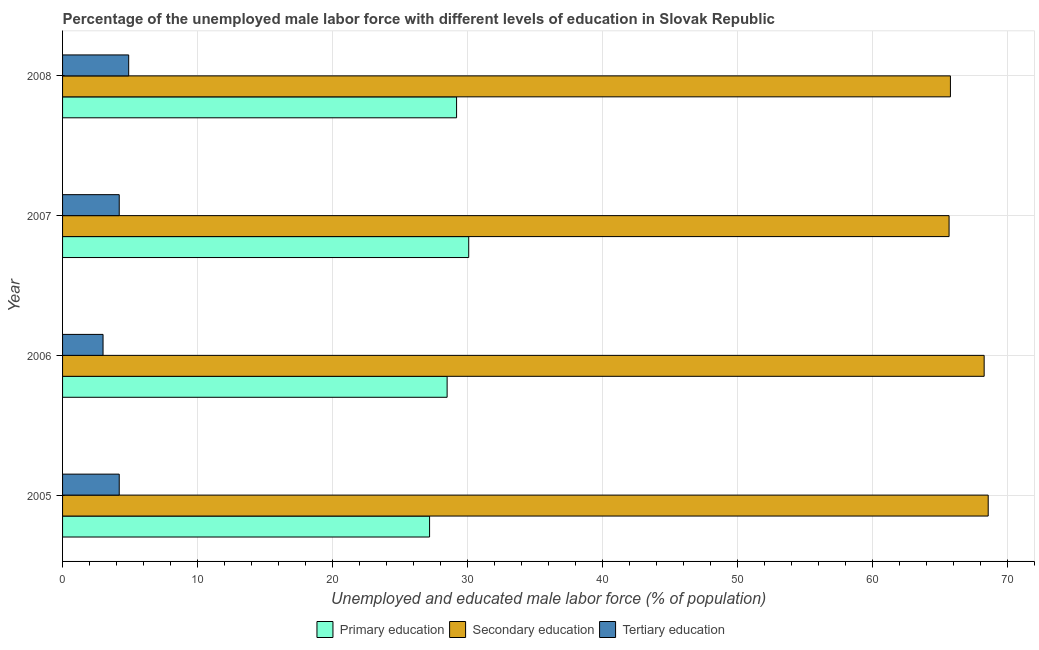How many groups of bars are there?
Offer a very short reply. 4. Are the number of bars per tick equal to the number of legend labels?
Make the answer very short. Yes. How many bars are there on the 4th tick from the bottom?
Ensure brevity in your answer.  3. What is the label of the 3rd group of bars from the top?
Give a very brief answer. 2006. In how many cases, is the number of bars for a given year not equal to the number of legend labels?
Offer a terse response. 0. What is the percentage of male labor force who received tertiary education in 2005?
Keep it short and to the point. 4.2. Across all years, what is the maximum percentage of male labor force who received primary education?
Provide a short and direct response. 30.1. Across all years, what is the minimum percentage of male labor force who received secondary education?
Your answer should be compact. 65.7. What is the total percentage of male labor force who received tertiary education in the graph?
Keep it short and to the point. 16.3. What is the difference between the percentage of male labor force who received primary education in 2005 and that in 2008?
Provide a succinct answer. -2. What is the difference between the percentage of male labor force who received secondary education in 2006 and the percentage of male labor force who received primary education in 2005?
Offer a very short reply. 41.1. What is the average percentage of male labor force who received tertiary education per year?
Provide a short and direct response. 4.08. In the year 2008, what is the difference between the percentage of male labor force who received secondary education and percentage of male labor force who received tertiary education?
Your answer should be compact. 60.9. What is the ratio of the percentage of male labor force who received secondary education in 2005 to that in 2008?
Offer a very short reply. 1.04. Is the percentage of male labor force who received tertiary education in 2005 less than that in 2007?
Make the answer very short. No. Is the difference between the percentage of male labor force who received secondary education in 2006 and 2007 greater than the difference between the percentage of male labor force who received tertiary education in 2006 and 2007?
Give a very brief answer. Yes. What is the difference between the highest and the lowest percentage of male labor force who received primary education?
Ensure brevity in your answer.  2.9. What does the 2nd bar from the top in 2006 represents?
Offer a terse response. Secondary education. What does the 3rd bar from the bottom in 2007 represents?
Provide a short and direct response. Tertiary education. How many bars are there?
Your answer should be compact. 12. How many years are there in the graph?
Make the answer very short. 4. Are the values on the major ticks of X-axis written in scientific E-notation?
Your response must be concise. No. Does the graph contain grids?
Give a very brief answer. Yes. Where does the legend appear in the graph?
Your answer should be very brief. Bottom center. How many legend labels are there?
Your response must be concise. 3. What is the title of the graph?
Ensure brevity in your answer.  Percentage of the unemployed male labor force with different levels of education in Slovak Republic. What is the label or title of the X-axis?
Your response must be concise. Unemployed and educated male labor force (% of population). What is the label or title of the Y-axis?
Your answer should be compact. Year. What is the Unemployed and educated male labor force (% of population) in Primary education in 2005?
Give a very brief answer. 27.2. What is the Unemployed and educated male labor force (% of population) in Secondary education in 2005?
Your answer should be compact. 68.6. What is the Unemployed and educated male labor force (% of population) in Tertiary education in 2005?
Keep it short and to the point. 4.2. What is the Unemployed and educated male labor force (% of population) in Primary education in 2006?
Keep it short and to the point. 28.5. What is the Unemployed and educated male labor force (% of population) of Secondary education in 2006?
Offer a terse response. 68.3. What is the Unemployed and educated male labor force (% of population) of Tertiary education in 2006?
Provide a succinct answer. 3. What is the Unemployed and educated male labor force (% of population) in Primary education in 2007?
Make the answer very short. 30.1. What is the Unemployed and educated male labor force (% of population) in Secondary education in 2007?
Keep it short and to the point. 65.7. What is the Unemployed and educated male labor force (% of population) of Tertiary education in 2007?
Provide a succinct answer. 4.2. What is the Unemployed and educated male labor force (% of population) of Primary education in 2008?
Keep it short and to the point. 29.2. What is the Unemployed and educated male labor force (% of population) of Secondary education in 2008?
Your response must be concise. 65.8. What is the Unemployed and educated male labor force (% of population) of Tertiary education in 2008?
Make the answer very short. 4.9. Across all years, what is the maximum Unemployed and educated male labor force (% of population) in Primary education?
Provide a short and direct response. 30.1. Across all years, what is the maximum Unemployed and educated male labor force (% of population) in Secondary education?
Your response must be concise. 68.6. Across all years, what is the maximum Unemployed and educated male labor force (% of population) in Tertiary education?
Make the answer very short. 4.9. Across all years, what is the minimum Unemployed and educated male labor force (% of population) of Primary education?
Keep it short and to the point. 27.2. Across all years, what is the minimum Unemployed and educated male labor force (% of population) of Secondary education?
Provide a short and direct response. 65.7. What is the total Unemployed and educated male labor force (% of population) of Primary education in the graph?
Offer a very short reply. 115. What is the total Unemployed and educated male labor force (% of population) of Secondary education in the graph?
Your answer should be very brief. 268.4. What is the total Unemployed and educated male labor force (% of population) of Tertiary education in the graph?
Keep it short and to the point. 16.3. What is the difference between the Unemployed and educated male labor force (% of population) in Secondary education in 2005 and that in 2006?
Offer a terse response. 0.3. What is the difference between the Unemployed and educated male labor force (% of population) in Tertiary education in 2005 and that in 2006?
Make the answer very short. 1.2. What is the difference between the Unemployed and educated male labor force (% of population) in Primary education in 2005 and that in 2008?
Provide a succinct answer. -2. What is the difference between the Unemployed and educated male labor force (% of population) of Primary education in 2006 and that in 2007?
Ensure brevity in your answer.  -1.6. What is the difference between the Unemployed and educated male labor force (% of population) of Secondary education in 2006 and that in 2007?
Provide a short and direct response. 2.6. What is the difference between the Unemployed and educated male labor force (% of population) in Tertiary education in 2006 and that in 2007?
Offer a very short reply. -1.2. What is the difference between the Unemployed and educated male labor force (% of population) in Secondary education in 2006 and that in 2008?
Provide a short and direct response. 2.5. What is the difference between the Unemployed and educated male labor force (% of population) of Secondary education in 2007 and that in 2008?
Ensure brevity in your answer.  -0.1. What is the difference between the Unemployed and educated male labor force (% of population) in Primary education in 2005 and the Unemployed and educated male labor force (% of population) in Secondary education in 2006?
Your answer should be very brief. -41.1. What is the difference between the Unemployed and educated male labor force (% of population) of Primary education in 2005 and the Unemployed and educated male labor force (% of population) of Tertiary education in 2006?
Provide a succinct answer. 24.2. What is the difference between the Unemployed and educated male labor force (% of population) of Secondary education in 2005 and the Unemployed and educated male labor force (% of population) of Tertiary education in 2006?
Offer a very short reply. 65.6. What is the difference between the Unemployed and educated male labor force (% of population) of Primary education in 2005 and the Unemployed and educated male labor force (% of population) of Secondary education in 2007?
Offer a very short reply. -38.5. What is the difference between the Unemployed and educated male labor force (% of population) in Primary education in 2005 and the Unemployed and educated male labor force (% of population) in Tertiary education in 2007?
Offer a very short reply. 23. What is the difference between the Unemployed and educated male labor force (% of population) in Secondary education in 2005 and the Unemployed and educated male labor force (% of population) in Tertiary education in 2007?
Your answer should be compact. 64.4. What is the difference between the Unemployed and educated male labor force (% of population) of Primary education in 2005 and the Unemployed and educated male labor force (% of population) of Secondary education in 2008?
Your answer should be compact. -38.6. What is the difference between the Unemployed and educated male labor force (% of population) of Primary education in 2005 and the Unemployed and educated male labor force (% of population) of Tertiary education in 2008?
Your answer should be very brief. 22.3. What is the difference between the Unemployed and educated male labor force (% of population) of Secondary education in 2005 and the Unemployed and educated male labor force (% of population) of Tertiary education in 2008?
Keep it short and to the point. 63.7. What is the difference between the Unemployed and educated male labor force (% of population) of Primary education in 2006 and the Unemployed and educated male labor force (% of population) of Secondary education in 2007?
Your response must be concise. -37.2. What is the difference between the Unemployed and educated male labor force (% of population) of Primary education in 2006 and the Unemployed and educated male labor force (% of population) of Tertiary education in 2007?
Your answer should be compact. 24.3. What is the difference between the Unemployed and educated male labor force (% of population) of Secondary education in 2006 and the Unemployed and educated male labor force (% of population) of Tertiary education in 2007?
Your answer should be compact. 64.1. What is the difference between the Unemployed and educated male labor force (% of population) of Primary education in 2006 and the Unemployed and educated male labor force (% of population) of Secondary education in 2008?
Provide a succinct answer. -37.3. What is the difference between the Unemployed and educated male labor force (% of population) of Primary education in 2006 and the Unemployed and educated male labor force (% of population) of Tertiary education in 2008?
Your answer should be very brief. 23.6. What is the difference between the Unemployed and educated male labor force (% of population) in Secondary education in 2006 and the Unemployed and educated male labor force (% of population) in Tertiary education in 2008?
Make the answer very short. 63.4. What is the difference between the Unemployed and educated male labor force (% of population) in Primary education in 2007 and the Unemployed and educated male labor force (% of population) in Secondary education in 2008?
Your answer should be compact. -35.7. What is the difference between the Unemployed and educated male labor force (% of population) of Primary education in 2007 and the Unemployed and educated male labor force (% of population) of Tertiary education in 2008?
Your response must be concise. 25.2. What is the difference between the Unemployed and educated male labor force (% of population) of Secondary education in 2007 and the Unemployed and educated male labor force (% of population) of Tertiary education in 2008?
Offer a very short reply. 60.8. What is the average Unemployed and educated male labor force (% of population) in Primary education per year?
Provide a succinct answer. 28.75. What is the average Unemployed and educated male labor force (% of population) in Secondary education per year?
Provide a short and direct response. 67.1. What is the average Unemployed and educated male labor force (% of population) of Tertiary education per year?
Offer a very short reply. 4.08. In the year 2005, what is the difference between the Unemployed and educated male labor force (% of population) in Primary education and Unemployed and educated male labor force (% of population) in Secondary education?
Your answer should be compact. -41.4. In the year 2005, what is the difference between the Unemployed and educated male labor force (% of population) of Secondary education and Unemployed and educated male labor force (% of population) of Tertiary education?
Offer a terse response. 64.4. In the year 2006, what is the difference between the Unemployed and educated male labor force (% of population) in Primary education and Unemployed and educated male labor force (% of population) in Secondary education?
Offer a terse response. -39.8. In the year 2006, what is the difference between the Unemployed and educated male labor force (% of population) in Secondary education and Unemployed and educated male labor force (% of population) in Tertiary education?
Ensure brevity in your answer.  65.3. In the year 2007, what is the difference between the Unemployed and educated male labor force (% of population) of Primary education and Unemployed and educated male labor force (% of population) of Secondary education?
Provide a succinct answer. -35.6. In the year 2007, what is the difference between the Unemployed and educated male labor force (% of population) of Primary education and Unemployed and educated male labor force (% of population) of Tertiary education?
Provide a succinct answer. 25.9. In the year 2007, what is the difference between the Unemployed and educated male labor force (% of population) in Secondary education and Unemployed and educated male labor force (% of population) in Tertiary education?
Offer a very short reply. 61.5. In the year 2008, what is the difference between the Unemployed and educated male labor force (% of population) in Primary education and Unemployed and educated male labor force (% of population) in Secondary education?
Your response must be concise. -36.6. In the year 2008, what is the difference between the Unemployed and educated male labor force (% of population) in Primary education and Unemployed and educated male labor force (% of population) in Tertiary education?
Make the answer very short. 24.3. In the year 2008, what is the difference between the Unemployed and educated male labor force (% of population) of Secondary education and Unemployed and educated male labor force (% of population) of Tertiary education?
Offer a terse response. 60.9. What is the ratio of the Unemployed and educated male labor force (% of population) in Primary education in 2005 to that in 2006?
Keep it short and to the point. 0.95. What is the ratio of the Unemployed and educated male labor force (% of population) in Secondary education in 2005 to that in 2006?
Your response must be concise. 1. What is the ratio of the Unemployed and educated male labor force (% of population) of Tertiary education in 2005 to that in 2006?
Provide a succinct answer. 1.4. What is the ratio of the Unemployed and educated male labor force (% of population) in Primary education in 2005 to that in 2007?
Your response must be concise. 0.9. What is the ratio of the Unemployed and educated male labor force (% of population) in Secondary education in 2005 to that in 2007?
Offer a terse response. 1.04. What is the ratio of the Unemployed and educated male labor force (% of population) of Primary education in 2005 to that in 2008?
Keep it short and to the point. 0.93. What is the ratio of the Unemployed and educated male labor force (% of population) in Secondary education in 2005 to that in 2008?
Offer a terse response. 1.04. What is the ratio of the Unemployed and educated male labor force (% of population) of Tertiary education in 2005 to that in 2008?
Give a very brief answer. 0.86. What is the ratio of the Unemployed and educated male labor force (% of population) in Primary education in 2006 to that in 2007?
Ensure brevity in your answer.  0.95. What is the ratio of the Unemployed and educated male labor force (% of population) in Secondary education in 2006 to that in 2007?
Your answer should be compact. 1.04. What is the ratio of the Unemployed and educated male labor force (% of population) in Primary education in 2006 to that in 2008?
Your answer should be compact. 0.98. What is the ratio of the Unemployed and educated male labor force (% of population) of Secondary education in 2006 to that in 2008?
Ensure brevity in your answer.  1.04. What is the ratio of the Unemployed and educated male labor force (% of population) of Tertiary education in 2006 to that in 2008?
Give a very brief answer. 0.61. What is the ratio of the Unemployed and educated male labor force (% of population) in Primary education in 2007 to that in 2008?
Your answer should be very brief. 1.03. What is the ratio of the Unemployed and educated male labor force (% of population) in Secondary education in 2007 to that in 2008?
Ensure brevity in your answer.  1. What is the ratio of the Unemployed and educated male labor force (% of population) in Tertiary education in 2007 to that in 2008?
Your response must be concise. 0.86. What is the difference between the highest and the second highest Unemployed and educated male labor force (% of population) of Primary education?
Keep it short and to the point. 0.9. What is the difference between the highest and the lowest Unemployed and educated male labor force (% of population) in Primary education?
Ensure brevity in your answer.  2.9. What is the difference between the highest and the lowest Unemployed and educated male labor force (% of population) in Tertiary education?
Offer a very short reply. 1.9. 